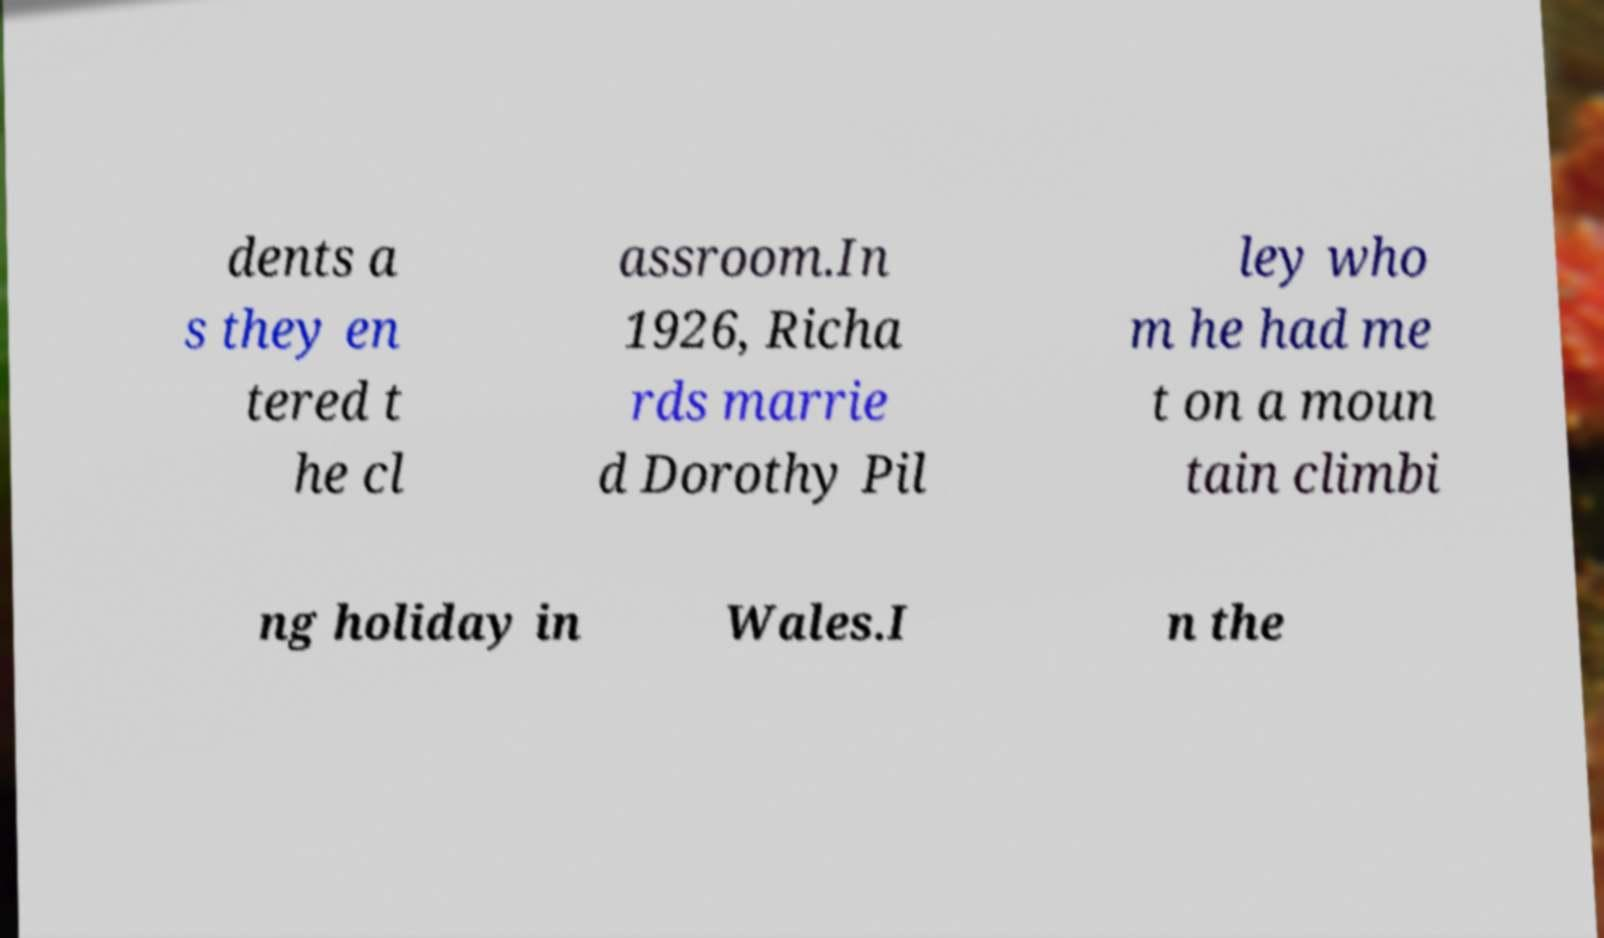Can you read and provide the text displayed in the image?This photo seems to have some interesting text. Can you extract and type it out for me? dents a s they en tered t he cl assroom.In 1926, Richa rds marrie d Dorothy Pil ley who m he had me t on a moun tain climbi ng holiday in Wales.I n the 